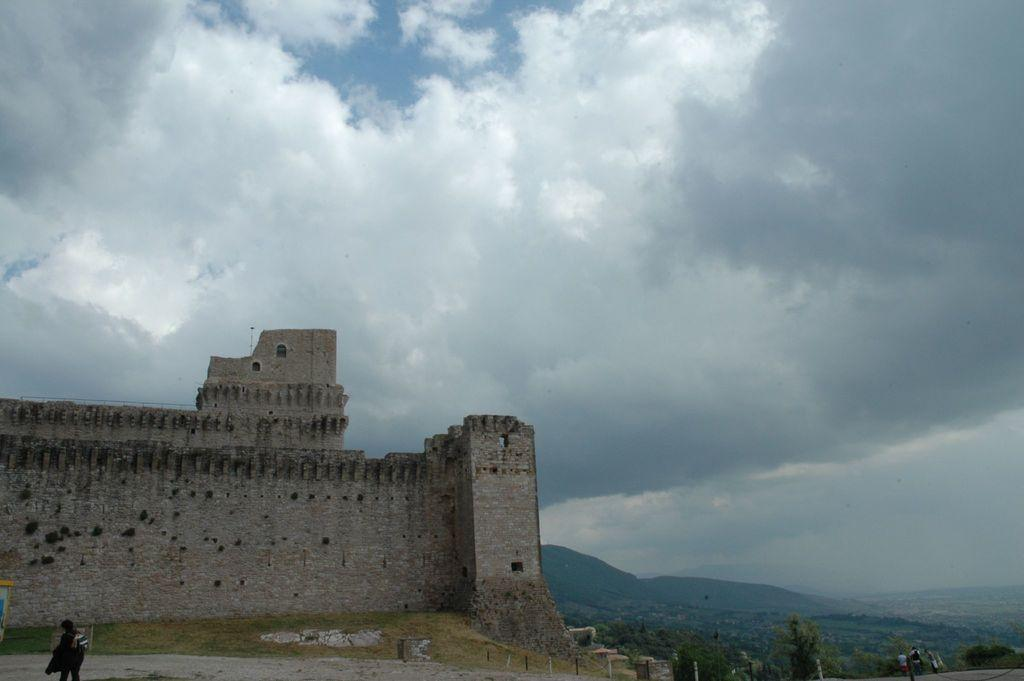What type of structure is present in the image? There is a building in the image. What other natural elements can be seen in the image? There are trees in the image. Are there any people visible in the image? Yes, there are persons in the image. What can be seen in the background of the image? The sky is visible in the background of the image. What type of coil is being used by the persons in the image? There is no coil present in the image; it features a building, trees, and persons. Can you provide a suggestion for a new feature to add to the image? As I am only looking at the image and not creating it, I cannot provide a suggestion for a new feature to add. 